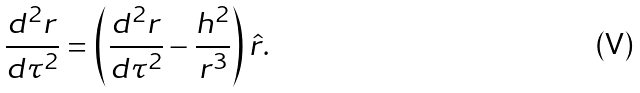Convert formula to latex. <formula><loc_0><loc_0><loc_500><loc_500>\frac { d ^ { 2 } r } { d \tau ^ { 2 } } = \left ( \frac { d ^ { 2 } r } { d \tau ^ { 2 } } - \frac { h ^ { 2 } } { r ^ { 3 } } \right ) \hat { r } .</formula> 